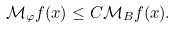<formula> <loc_0><loc_0><loc_500><loc_500>\mathcal { M } _ { \varphi } f ( x ) \leq C \mathcal { M } _ { B } f ( x ) .</formula> 